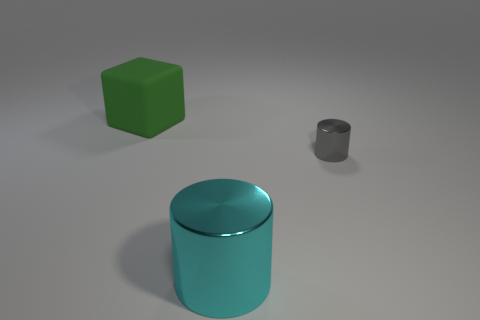What time of day do you think it is in this image, or is there any indication of time at all? The image doesn't provide clear indications of time of day, as it seems to be a controlled environment with consistent lighting, likely indoors or a computer-generated setting with neutral lighting. Could you describe the lighting and atmosphere? Of course! The lighting is soft and diffused, coming from an overhead source, casting subtle shadows beneath the objects. There's an overall calm and minimalist atmosphere, devoid of any distractions or background elements, which puts the focus entirely on the shapes. 